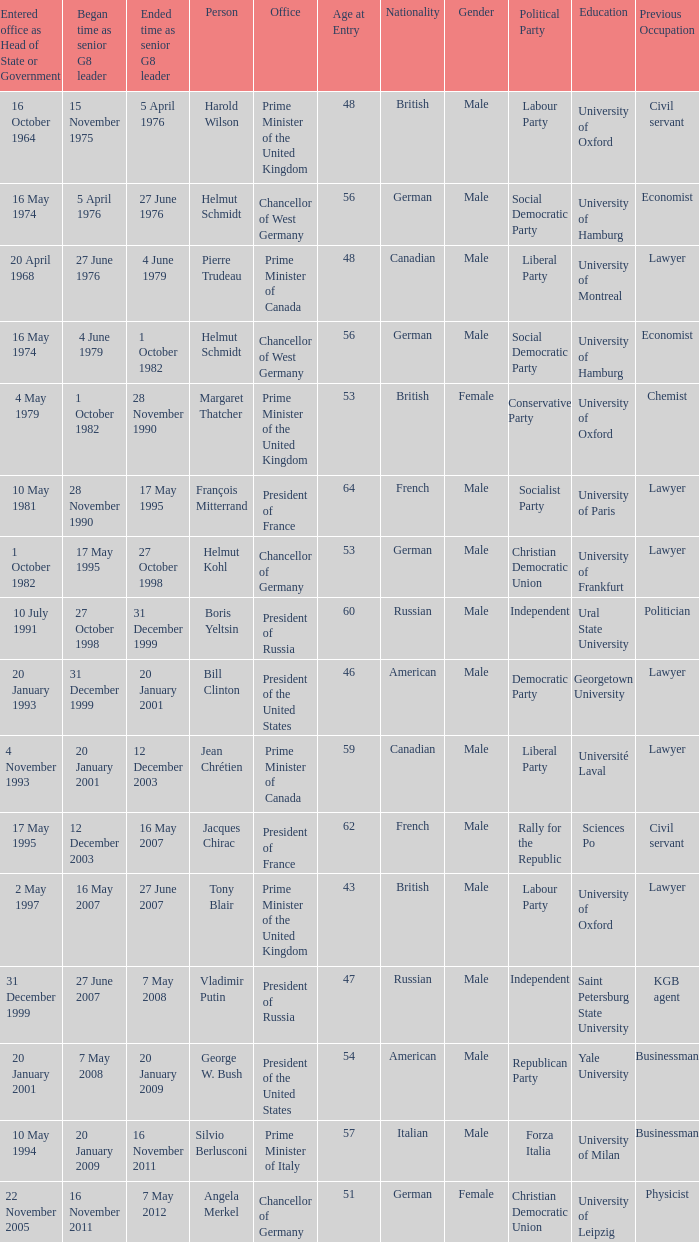When did Jacques Chirac stop being a G8 leader? 16 May 2007. 